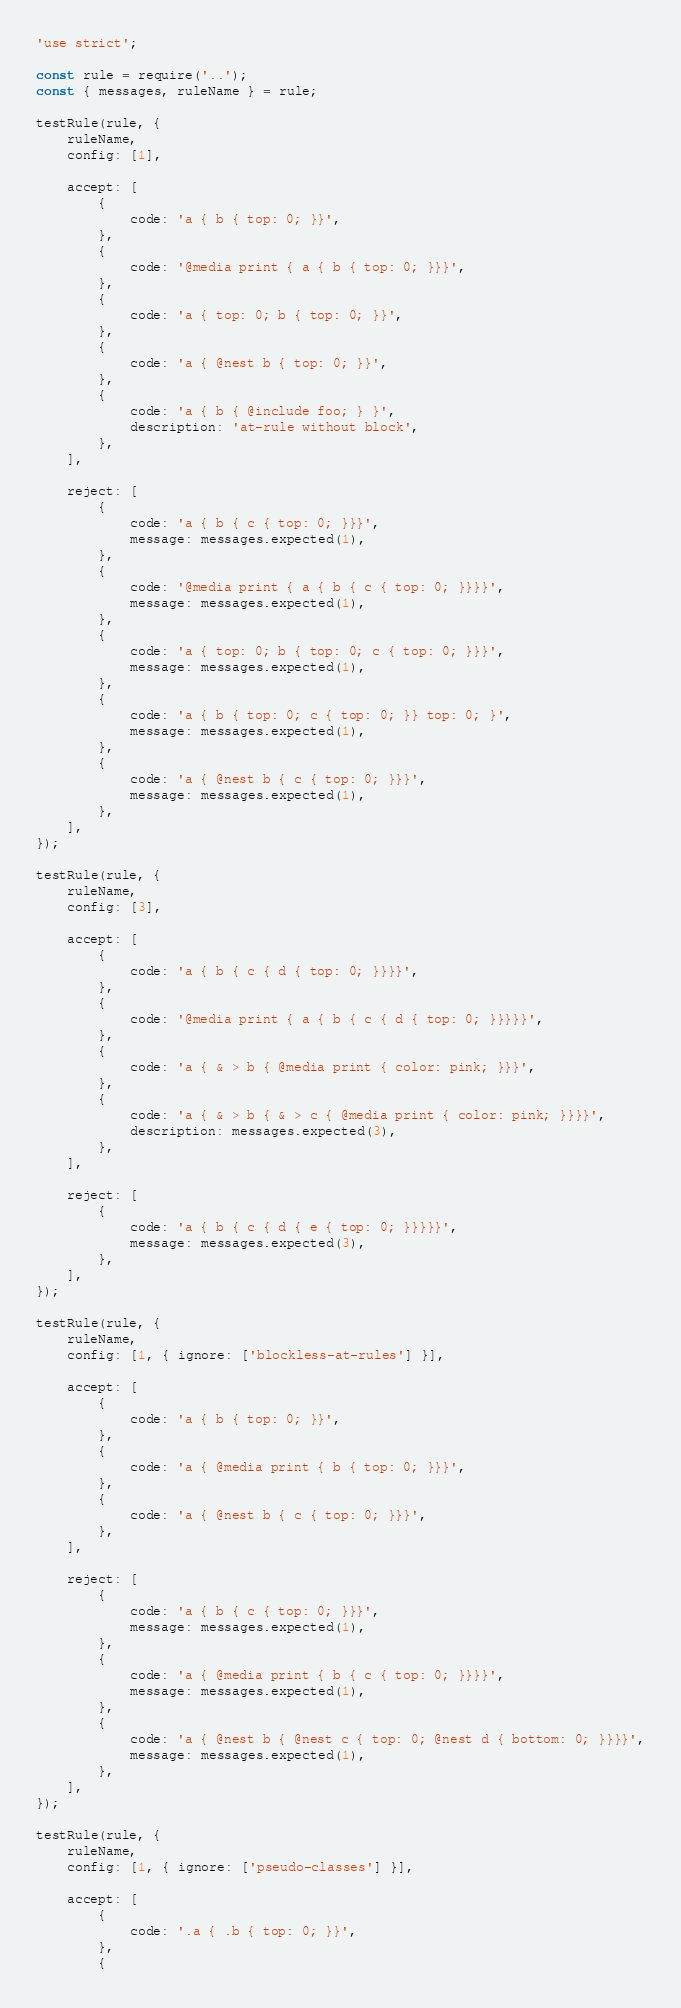Convert code to text. <code><loc_0><loc_0><loc_500><loc_500><_JavaScript_>'use strict';

const rule = require('..');
const { messages, ruleName } = rule;

testRule(rule, {
	ruleName,
	config: [1],

	accept: [
		{
			code: 'a { b { top: 0; }}',
		},
		{
			code: '@media print { a { b { top: 0; }}}',
		},
		{
			code: 'a { top: 0; b { top: 0; }}',
		},
		{
			code: 'a { @nest b { top: 0; }}',
		},
		{
			code: 'a { b { @include foo; } }',
			description: 'at-rule without block',
		},
	],

	reject: [
		{
			code: 'a { b { c { top: 0; }}}',
			message: messages.expected(1),
		},
		{
			code: '@media print { a { b { c { top: 0; }}}}',
			message: messages.expected(1),
		},
		{
			code: 'a { top: 0; b { top: 0; c { top: 0; }}}',
			message: messages.expected(1),
		},
		{
			code: 'a { b { top: 0; c { top: 0; }} top: 0; }',
			message: messages.expected(1),
		},
		{
			code: 'a { @nest b { c { top: 0; }}}',
			message: messages.expected(1),
		},
	],
});

testRule(rule, {
	ruleName,
	config: [3],

	accept: [
		{
			code: 'a { b { c { d { top: 0; }}}}',
		},
		{
			code: '@media print { a { b { c { d { top: 0; }}}}}',
		},
		{
			code: 'a { & > b { @media print { color: pink; }}}',
		},
		{
			code: 'a { & > b { & > c { @media print { color: pink; }}}}',
			description: messages.expected(3),
		},
	],

	reject: [
		{
			code: 'a { b { c { d { e { top: 0; }}}}}',
			message: messages.expected(3),
		},
	],
});

testRule(rule, {
	ruleName,
	config: [1, { ignore: ['blockless-at-rules'] }],

	accept: [
		{
			code: 'a { b { top: 0; }}',
		},
		{
			code: 'a { @media print { b { top: 0; }}}',
		},
		{
			code: 'a { @nest b { c { top: 0; }}}',
		},
	],

	reject: [
		{
			code: 'a { b { c { top: 0; }}}',
			message: messages.expected(1),
		},
		{
			code: 'a { @media print { b { c { top: 0; }}}}',
			message: messages.expected(1),
		},
		{
			code: 'a { @nest b { @nest c { top: 0; @nest d { bottom: 0; }}}}',
			message: messages.expected(1),
		},
	],
});

testRule(rule, {
	ruleName,
	config: [1, { ignore: ['pseudo-classes'] }],

	accept: [
		{
			code: '.a { .b { top: 0; }}',
		},
		{</code> 